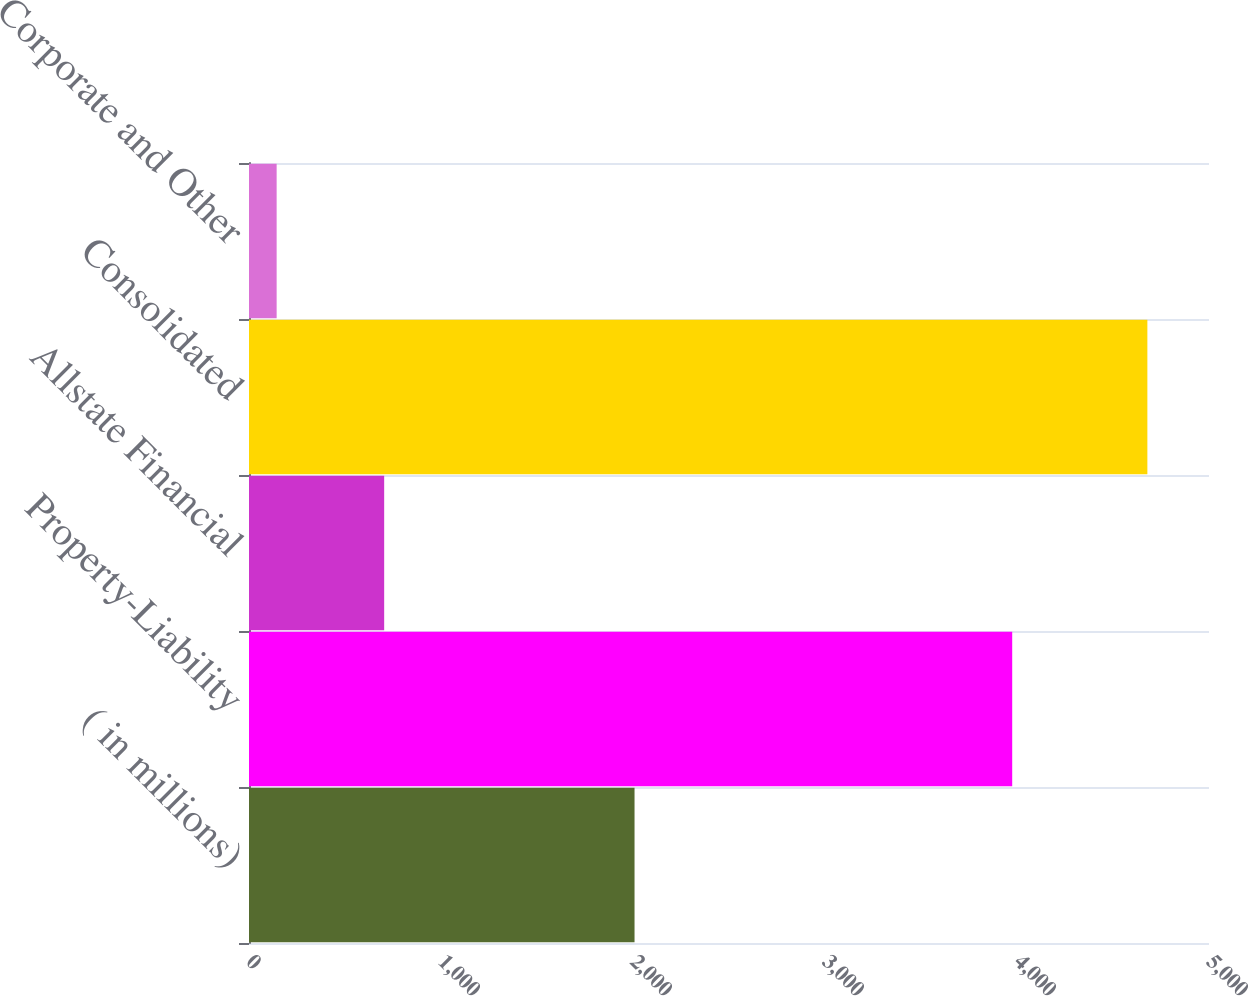Convert chart to OTSL. <chart><loc_0><loc_0><loc_500><loc_500><bar_chart><fcel>( in millions)<fcel>Property-Liability<fcel>Allstate Financial<fcel>Consolidated<fcel>Corporate and Other<nl><fcel>2008<fcel>3975<fcel>704<fcel>4679<fcel>144<nl></chart> 